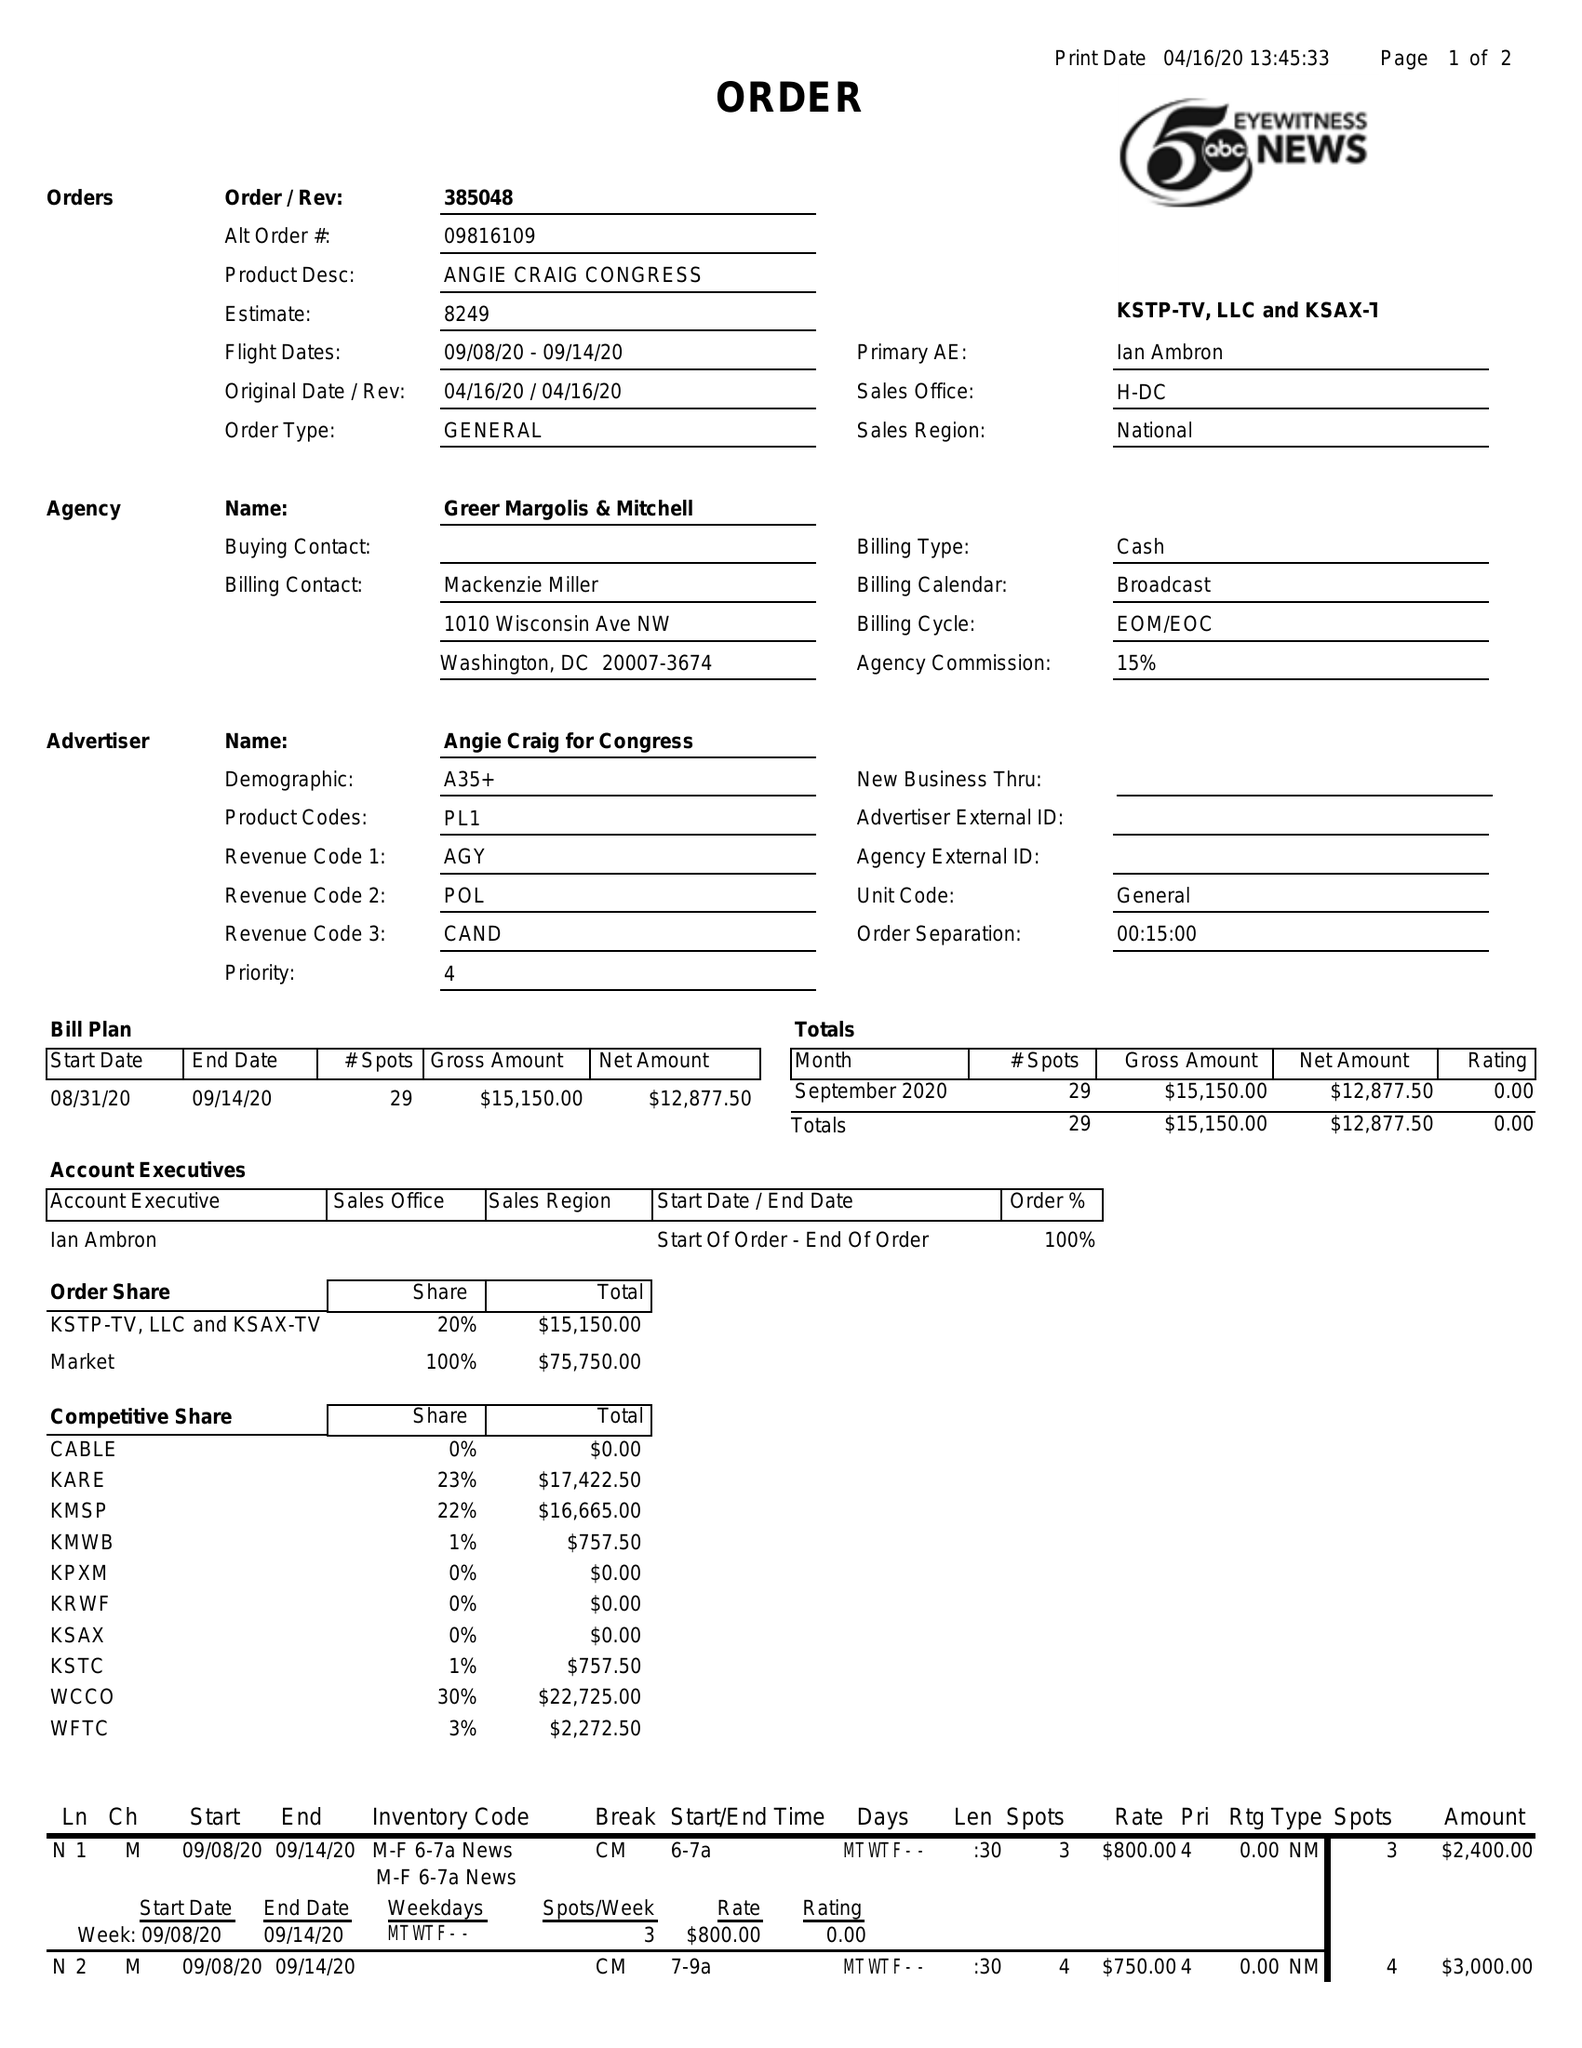What is the value for the advertiser?
Answer the question using a single word or phrase. ANGIE CRAIG FOR CONGRESS 